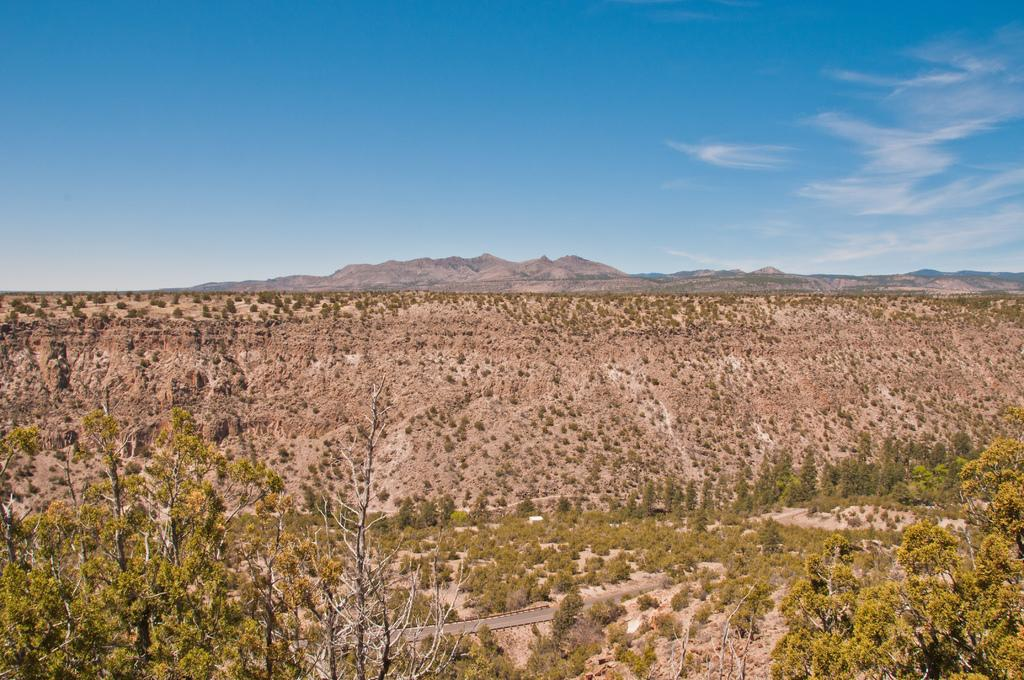What type of vegetation can be seen in the image? There are trees in the image. Can you describe the color of the trees? The trees are green and ash in color. What can be seen on the ground in the image? The ground is visible in the image. What type of man-made structure is present in the image? There is a road in the image. What is visible in the background of the image? There are mountains and the sky in the background of the image. How many chairs are placed around the competition area in the image? There are no chairs or competition area present in the image; it features trees, a road, and a background with mountains and the sky. What type of yarn is being used to create the patterns on the trees in the image? There is no yarn or patterns on the trees in the image; they are simply green and ash in color. 